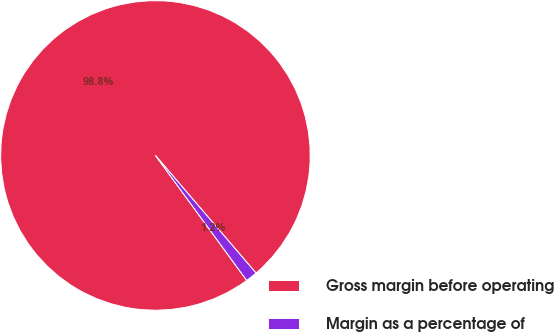Convert chart. <chart><loc_0><loc_0><loc_500><loc_500><pie_chart><fcel>Gross margin before operating<fcel>Margin as a percentage of<nl><fcel>98.78%<fcel>1.22%<nl></chart> 